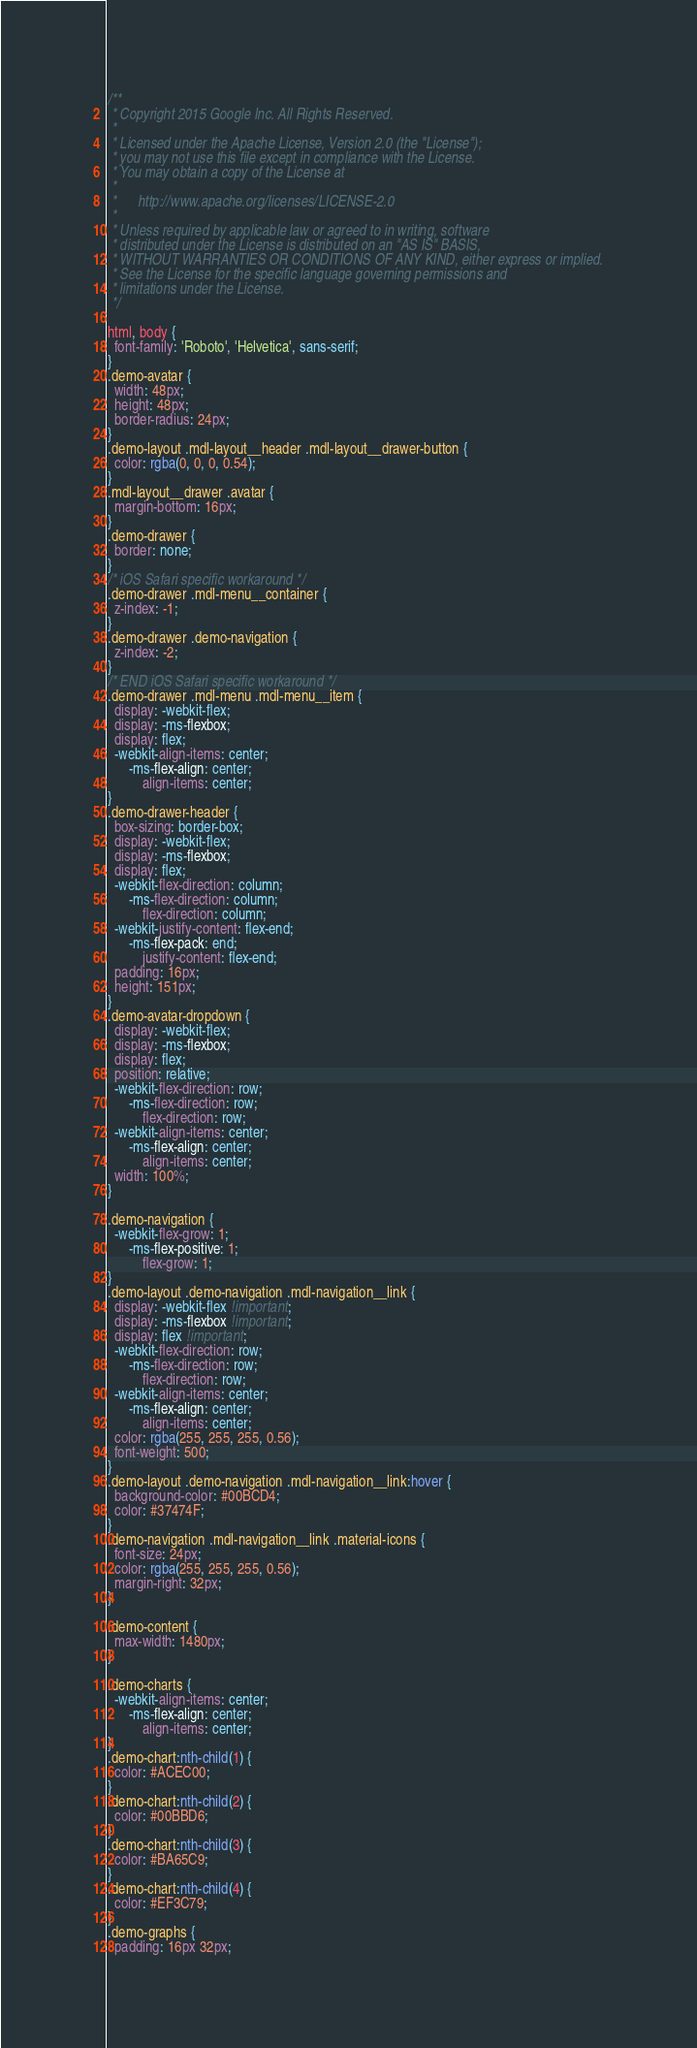<code> <loc_0><loc_0><loc_500><loc_500><_CSS_>/**
 * Copyright 2015 Google Inc. All Rights Reserved.
 *
 * Licensed under the Apache License, Version 2.0 (the "License");
 * you may not use this file except in compliance with the License.
 * You may obtain a copy of the License at
 *
 *      http://www.apache.org/licenses/LICENSE-2.0
 *
 * Unless required by applicable law or agreed to in writing, software
 * distributed under the License is distributed on an "AS IS" BASIS,
 * WITHOUT WARRANTIES OR CONDITIONS OF ANY KIND, either express or implied.
 * See the License for the specific language governing permissions and
 * limitations under the License.
 */

html, body {
  font-family: 'Roboto', 'Helvetica', sans-serif;
}
.demo-avatar {
  width: 48px;
  height: 48px;
  border-radius: 24px;
}
.demo-layout .mdl-layout__header .mdl-layout__drawer-button {
  color: rgba(0, 0, 0, 0.54);
}
.mdl-layout__drawer .avatar {
  margin-bottom: 16px;
}
.demo-drawer {
  border: none;
}
/* iOS Safari specific workaround */
.demo-drawer .mdl-menu__container {
  z-index: -1;
}
.demo-drawer .demo-navigation {
  z-index: -2;
}
/* END iOS Safari specific workaround */
.demo-drawer .mdl-menu .mdl-menu__item {
  display: -webkit-flex;
  display: -ms-flexbox;
  display: flex;
  -webkit-align-items: center;
      -ms-flex-align: center;
          align-items: center;
}
.demo-drawer-header {
  box-sizing: border-box;
  display: -webkit-flex;
  display: -ms-flexbox;
  display: flex;
  -webkit-flex-direction: column;
      -ms-flex-direction: column;
          flex-direction: column;
  -webkit-justify-content: flex-end;
      -ms-flex-pack: end;
          justify-content: flex-end;
  padding: 16px;
  height: 151px;
}
.demo-avatar-dropdown {
  display: -webkit-flex;
  display: -ms-flexbox;
  display: flex;
  position: relative;
  -webkit-flex-direction: row;
      -ms-flex-direction: row;
          flex-direction: row;
  -webkit-align-items: center;
      -ms-flex-align: center;
          align-items: center;
  width: 100%;
}

.demo-navigation {
  -webkit-flex-grow: 1;
      -ms-flex-positive: 1;
          flex-grow: 1;
}
.demo-layout .demo-navigation .mdl-navigation__link {
  display: -webkit-flex !important;
  display: -ms-flexbox !important;
  display: flex !important;
  -webkit-flex-direction: row;
      -ms-flex-direction: row;
          flex-direction: row;
  -webkit-align-items: center;
      -ms-flex-align: center;
          align-items: center;
  color: rgba(255, 255, 255, 0.56);
  font-weight: 500;
}
.demo-layout .demo-navigation .mdl-navigation__link:hover {
  background-color: #00BCD4;
  color: #37474F;
}
.demo-navigation .mdl-navigation__link .material-icons {
  font-size: 24px;
  color: rgba(255, 255, 255, 0.56);
  margin-right: 32px;
}

.demo-content {
  max-width: 1480px;
}

.demo-charts {
  -webkit-align-items: center;
      -ms-flex-align: center;
          align-items: center;
}
.demo-chart:nth-child(1) {
  color: #ACEC00;
}
.demo-chart:nth-child(2) {
  color: #00BBD6;
}
.demo-chart:nth-child(3) {
  color: #BA65C9;
}
.demo-chart:nth-child(4) {
  color: #EF3C79;
}
.demo-graphs {
  padding: 16px 32px;</code> 